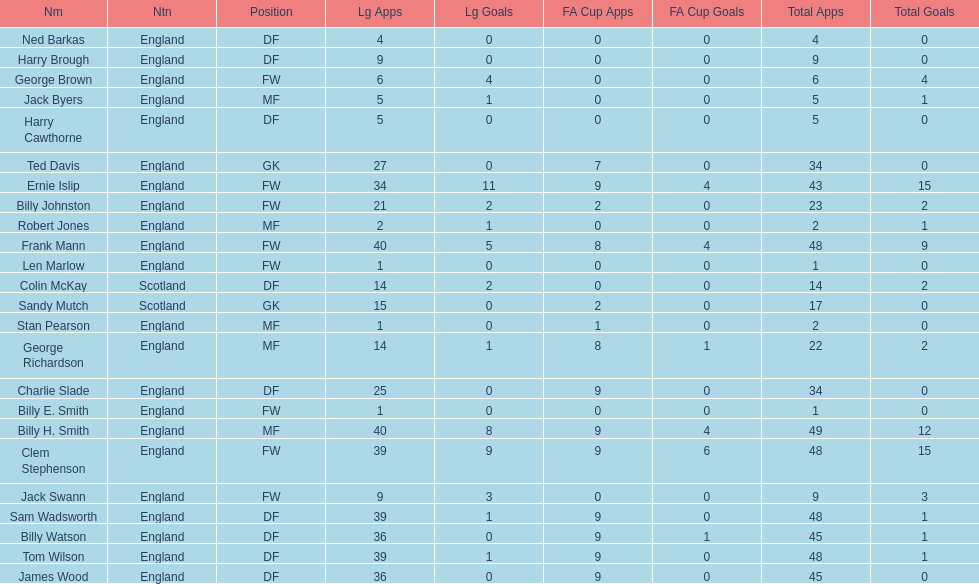Average number of goals scored by players from scotland 1. 